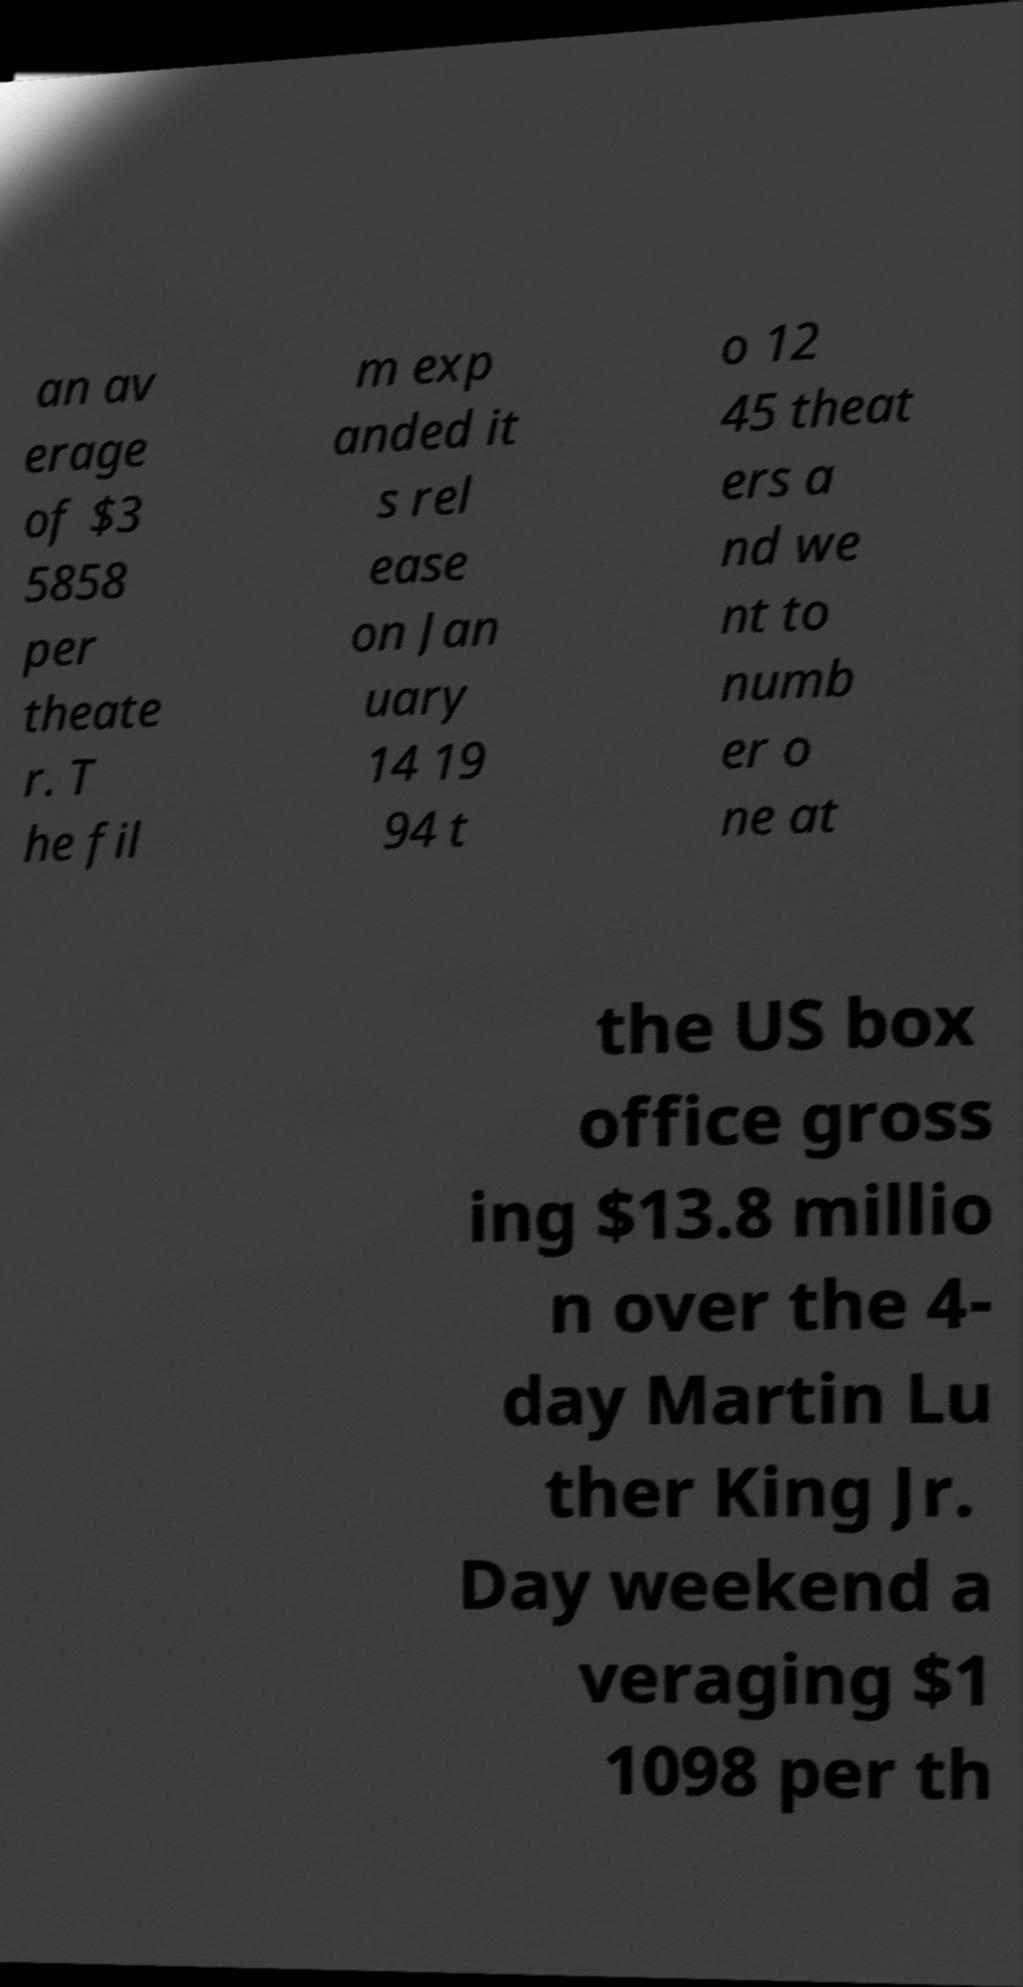Can you read and provide the text displayed in the image?This photo seems to have some interesting text. Can you extract and type it out for me? an av erage of $3 5858 per theate r. T he fil m exp anded it s rel ease on Jan uary 14 19 94 t o 12 45 theat ers a nd we nt to numb er o ne at the US box office gross ing $13.8 millio n over the 4- day Martin Lu ther King Jr. Day weekend a veraging $1 1098 per th 